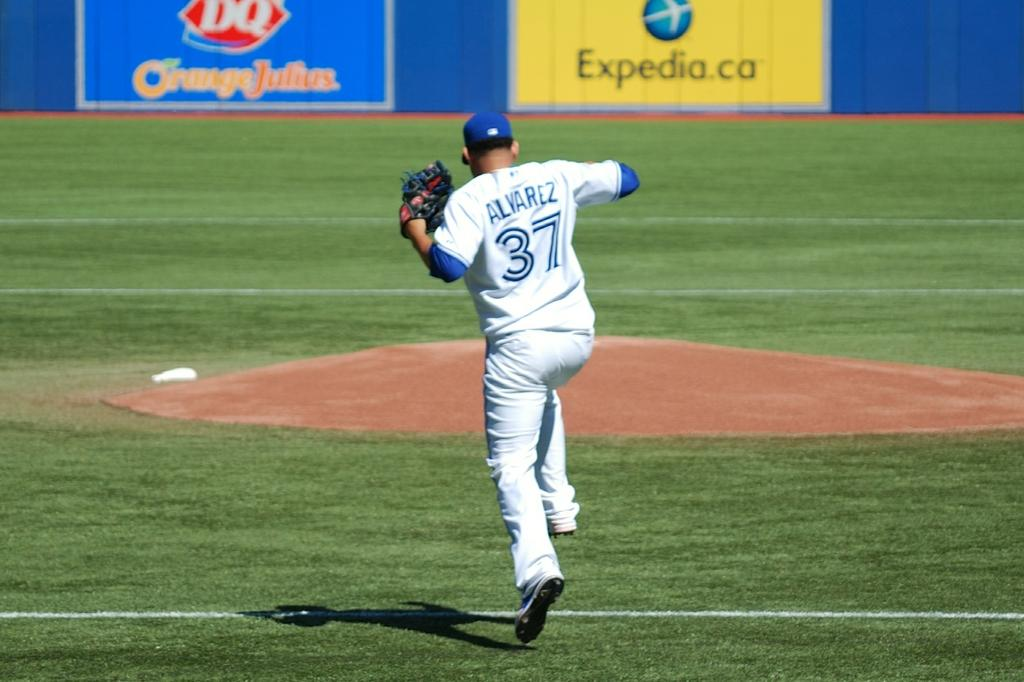What is the person in the image doing? The person is in the air, which suggests they might be flying or jumping. What protective gear is the person wearing? The person is wearing gloves and a cap. What can be seen in the background of the image? There is grass in the background, and it has white lines. What else is visible in the image? There are banners visible at the top of the image. What type of skirt is the person wearing in the image? There is no skirt visible in the image; the person is wearing gloves and a cap. How many trains can be seen passing by in the image? There are no trains present in the image. 